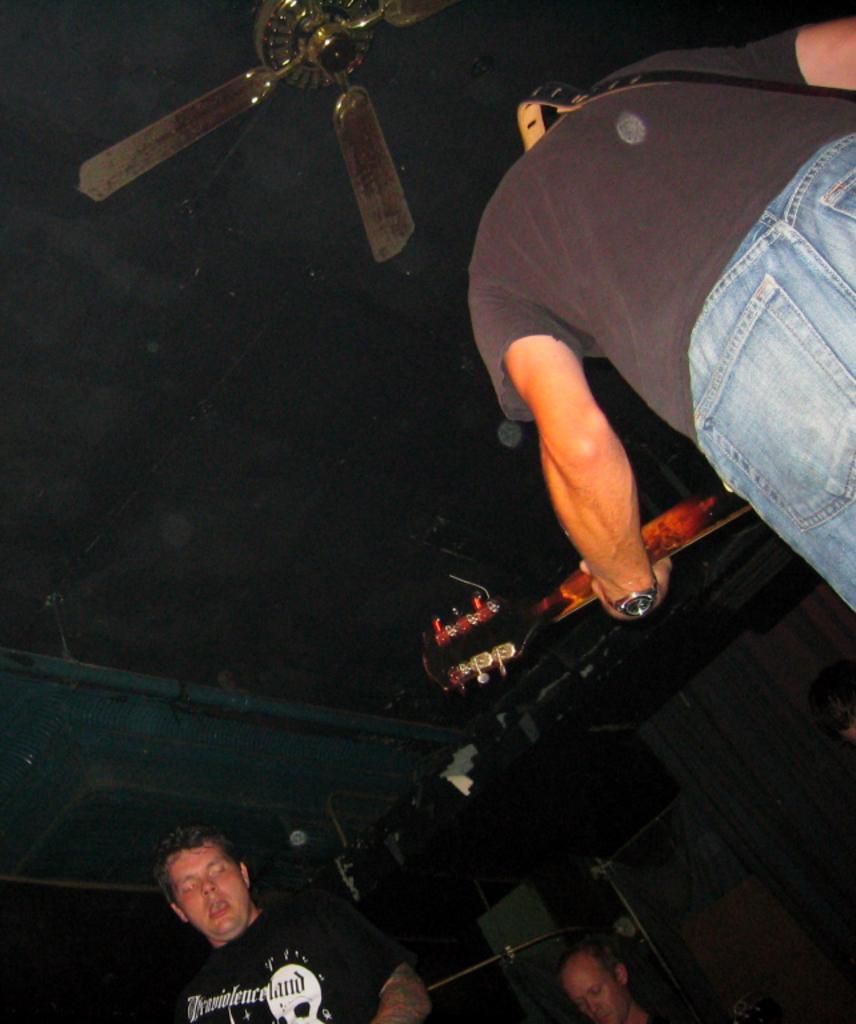Please provide a concise description of this image. The person wearing black dress is playing guitar and there are two persons in front of them and there is a fan in the top. 